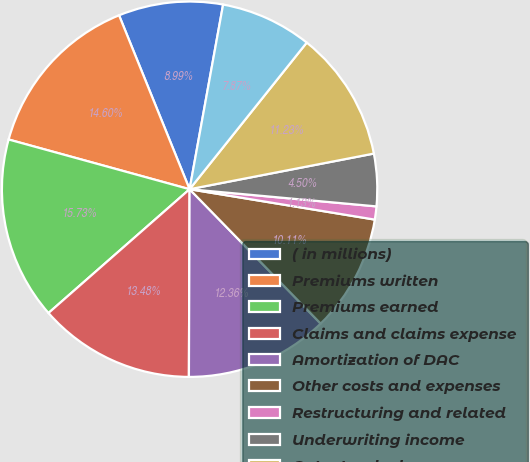<chart> <loc_0><loc_0><loc_500><loc_500><pie_chart><fcel>( in millions)<fcel>Premiums written<fcel>Premiums earned<fcel>Claims and claims expense<fcel>Amortization of DAC<fcel>Other costs and expenses<fcel>Restructuring and related<fcel>Underwriting income<fcel>Catastrophe losses<fcel>Standard auto (1)<nl><fcel>8.99%<fcel>14.6%<fcel>15.73%<fcel>13.48%<fcel>12.36%<fcel>10.11%<fcel>1.13%<fcel>4.5%<fcel>11.23%<fcel>7.87%<nl></chart> 